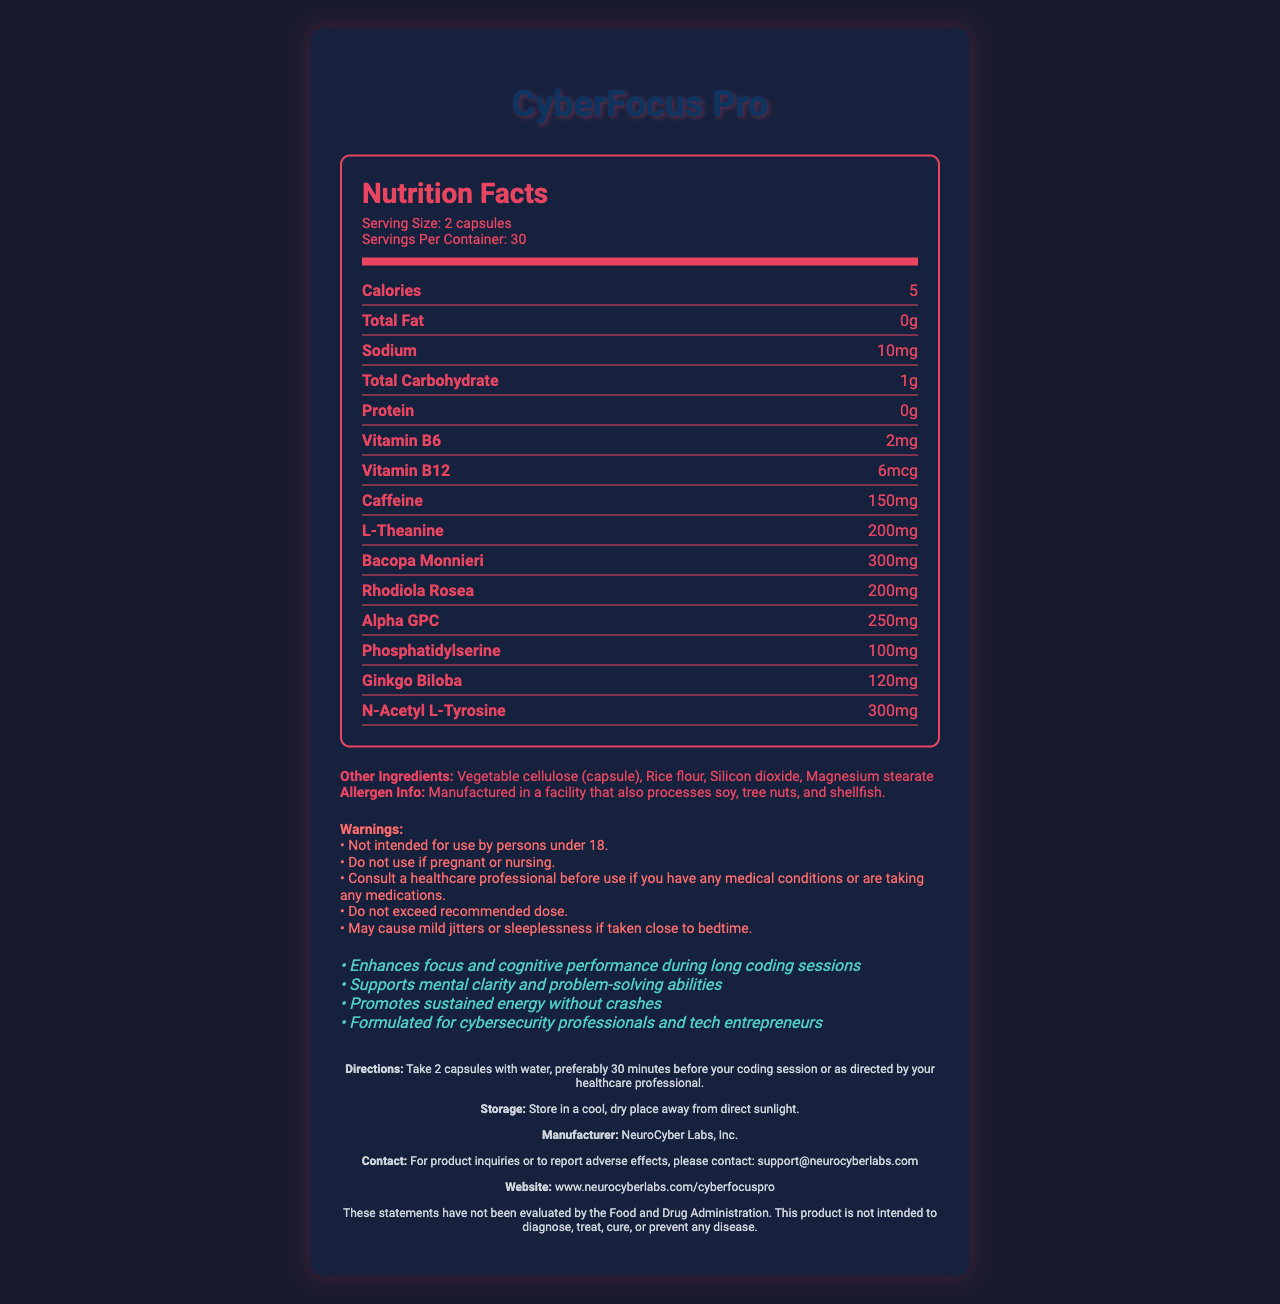what is the serving size? The document specifies the serving size as "2 capsules".
Answer: 2 capsules how many servings are there per container? The document mentions that there are 30 servings per container.
Answer: 30 what is the amount of caffeine per serving? The document lists the amount of caffeine per serving as "150mg".
Answer: 150mg how much sodium does one serving contain? The sodium content per serving is mentioned as "10mg".
Answer: 10mg where should the product be stored? The storage instructions indicate to store the product in a cool, dry place away from direct sunlight.
Answer: In a cool, dry place away from direct sunlight which ingredient is present in the highest amount? A. L-Theanine B. Bacopa Monnieri C. Alpha GPC D. N-Acetyl L-Tyrosine Bacopa Monnieri is present in 300mg, which is the highest among the listed ingredients.
Answer: B. Bacopa Monnieri what potential side effects are listed? The document warns that taking the supplement close to bedtime may cause mild jitters or sleeplessness.
Answer: Mild jitters or sleeplessness if taken close to bedtime how should the product be consumed? The directions specify taking 2 capsules with water, preferably 30 minutes before coding, or as directed by a healthcare professional.
Answer: Take 2 capsules with water, preferably 30 minutes before your coding session or as directed by your healthcare professional is CyberFocus Pro suitable for people under 18? The warnings explicitly state that the product is not intended for use by persons under 18.
Answer: No does the supplement contain any protein? The document shows that the protein content per serving is "0g".
Answer: No what are the specific benefits claimed by the product? The marketing claims section specifies these benefits.
Answer: Enhances focus and cognitive performance during long coding sessions, supports mental clarity and problem-solving abilities, promotes sustained energy without crashes, formulated for cybersecurity professionals and tech entrepreneurs which of the following ingredients is NOT listed on the label? 1. Silicon dioxide 2. Rice flour 3. Gelatin 4. Magnesium stearate The listed ingredients are vegetable cellulose (capsule), rice flour, silicon dioxide, and magnesium stearate, but not gelatin.
Answer: 3. Gelatin is this product evaluated by the FDA? The disclaimer states that these statements have not been evaluated by the Food and Drug Administration.
Answer: No does the supplement contain soy or tree nuts? The allergen info specifies that the product is manufactured in a facility that processes these allergens.
Answer: Manufactured in a facility that also processes soy, tree nuts, and shellfish. summarize the main idea of the document. This document provides a detailed overview of the benefits, ingredients, usage guidelines, and safety information for the CyberFocus Pro supplement, targeting those in tech-intensive fields.
Answer: CyberFocus Pro is a brain-boosting supplement aimed at enhancing focus and cognitive performance during long coding sessions. It contains various ingredients believed to support mental clarity, sustained energy, and problem-solving abilities. Designed for cybersecurity professionals and tech entrepreneurs, it comes with specific usage directions, potential warnings, and storage instructions. what is the manufacturer's contact information? The contact information listed for inquiries or reporting adverse effects is "support@neurocyberlabs.com".
Answer: support@neurocyberlabs.com how does L-Theanine in CyberFocus Pro support cognitive function? The document lists L-Theanine among the ingredients but does not provide specific details on how it supports cognitive function.
Answer: Not enough information what is the website for more information about CyberFocus Pro? The footer section provides the website "www.neurocyberlabs.com/cyberfocuspro".
Answer: www.neurocyberlabs.com/cyberfocuspro 